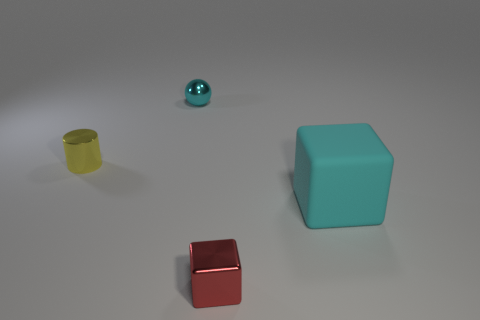Is there any other thing that is the same size as the cyan cube?
Keep it short and to the point. No. How many other objects are there of the same color as the cylinder?
Your answer should be very brief. 0. What number of yellow objects are tiny metallic cylinders or shiny blocks?
Your answer should be very brief. 1. There is a object that is in front of the large cyan rubber block; is its shape the same as the cyan object that is on the right side of the tiny red thing?
Provide a succinct answer. Yes. What number of other objects are the same material as the big cyan thing?
Your answer should be compact. 0. There is a cyan thing left of the block on the left side of the rubber cube; are there any rubber cubes on the left side of it?
Make the answer very short. No. Is the red block made of the same material as the large cube?
Offer a terse response. No. Is there any other thing that is the same shape as the tiny cyan shiny thing?
Ensure brevity in your answer.  No. The block that is behind the small thing that is in front of the tiny cylinder is made of what material?
Keep it short and to the point. Rubber. There is a shiny object in front of the matte thing; how big is it?
Provide a short and direct response. Small. 